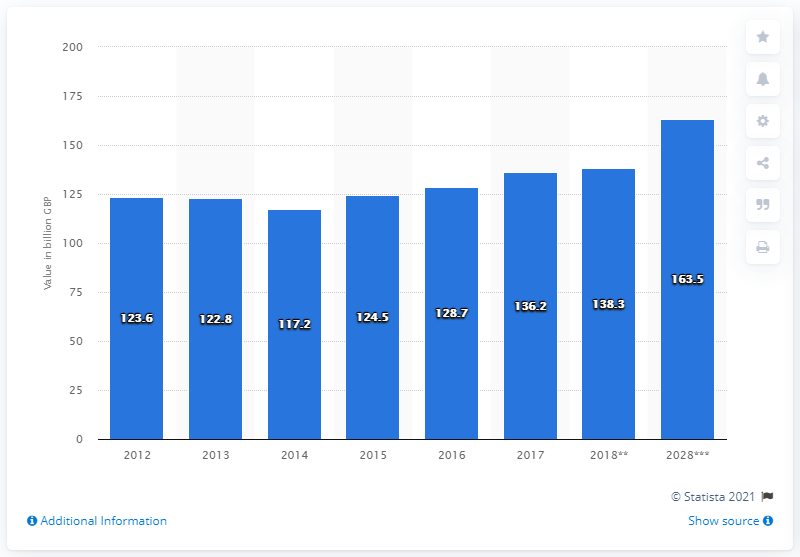Indicate a few pertinent items in this graphic. In 2017, the amount of domestic travel and tourism spending was $136.2 billion. 